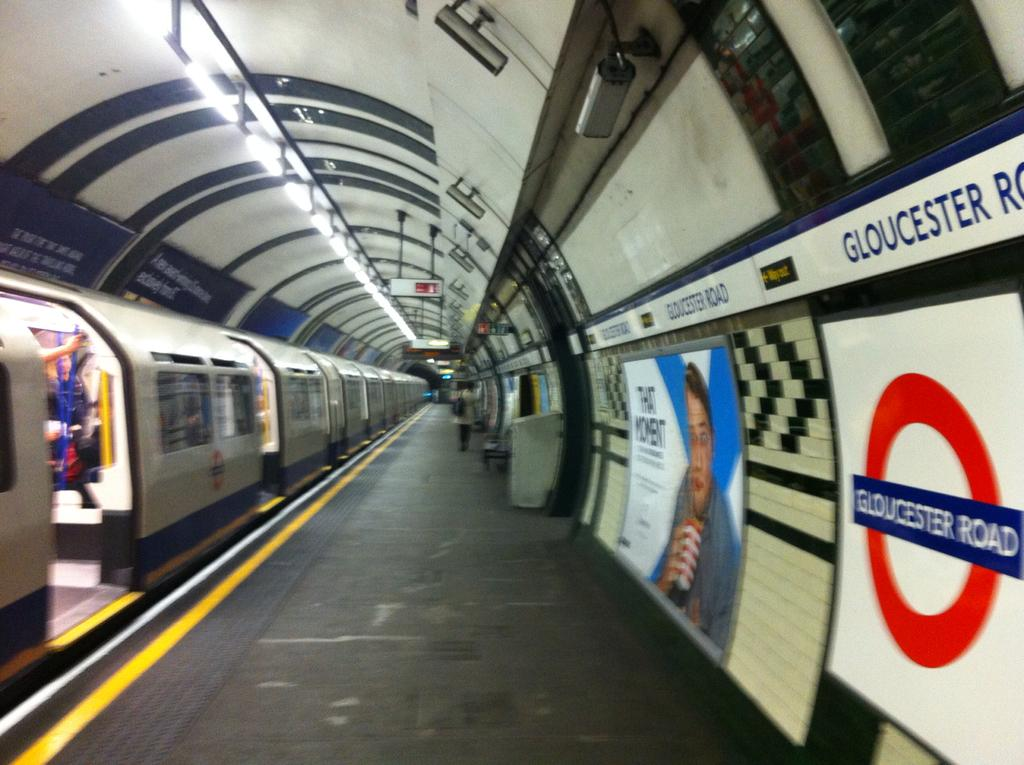<image>
Describe the image concisely. A subway train park beside a walkway with a Gloucester on the wall. 